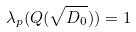<formula> <loc_0><loc_0><loc_500><loc_500>\lambda _ { p } ( Q ( \sqrt { D _ { 0 } } ) ) = 1</formula> 